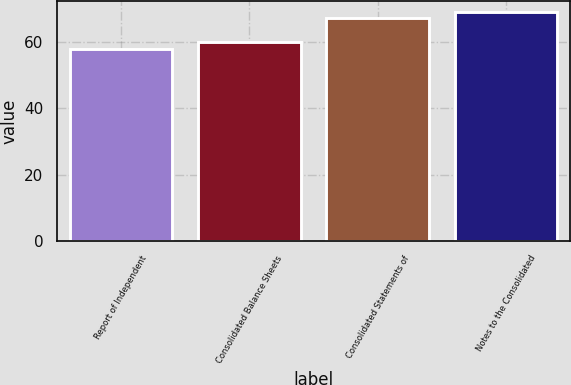Convert chart. <chart><loc_0><loc_0><loc_500><loc_500><bar_chart><fcel>Report of Independent<fcel>Consolidated Balance Sheets<fcel>Consolidated Statements of<fcel>Notes to the Consolidated<nl><fcel>58<fcel>60<fcel>67.1<fcel>69<nl></chart> 